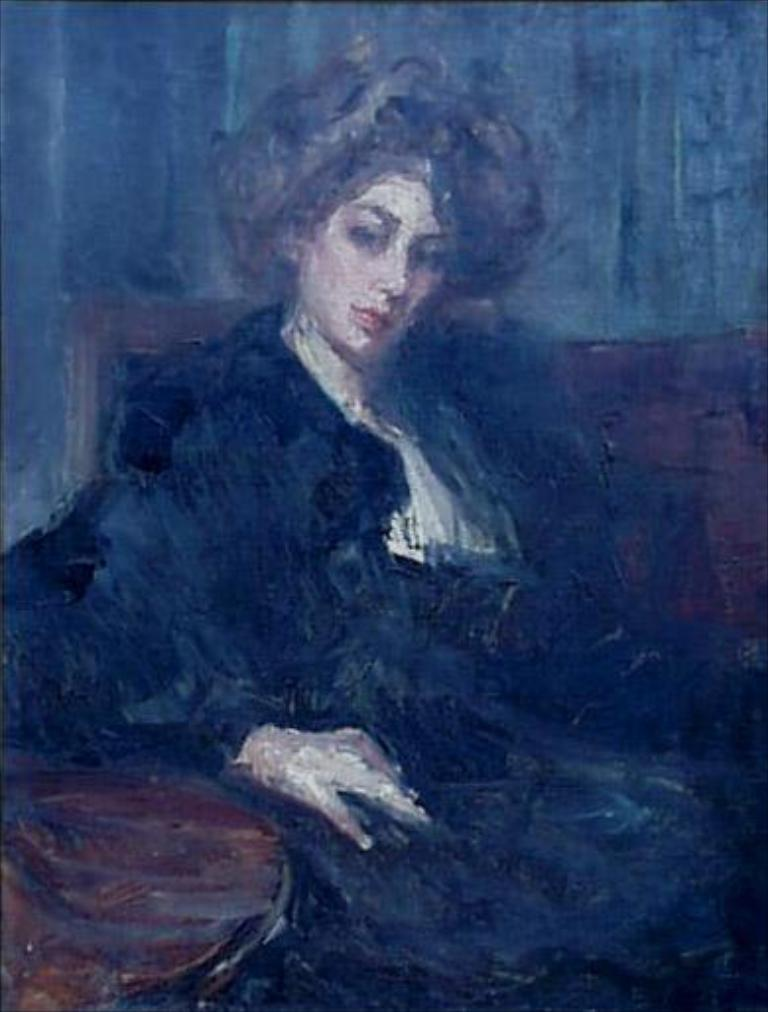What is depicted in the painting in the image? There is a painting of a woman in the image. What is the woman doing in the painting? The woman is sitting on a chair in the painting. What is the woman wearing in the painting? The woman is wearing a black dress in the painting. What can be seen in the background of the painting? There is a grey surface in the backdrop of the painting. What type of stamp can be seen on the woman's scarf in the image? There is no stamp or scarf present in the image; the woman is wearing a black dress. 